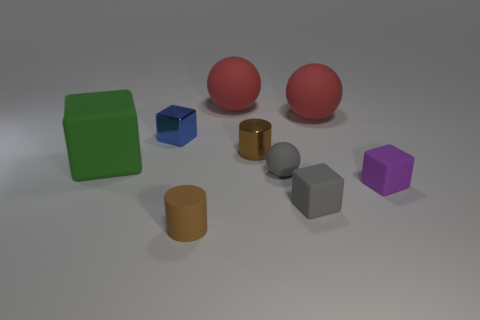Add 1 small gray spheres. How many objects exist? 10 Subtract all cylinders. How many objects are left? 7 Subtract 0 blue spheres. How many objects are left? 9 Subtract all purple blocks. Subtract all tiny cyan metallic things. How many objects are left? 8 Add 4 small gray spheres. How many small gray spheres are left? 5 Add 3 large red rubber spheres. How many large red rubber spheres exist? 5 